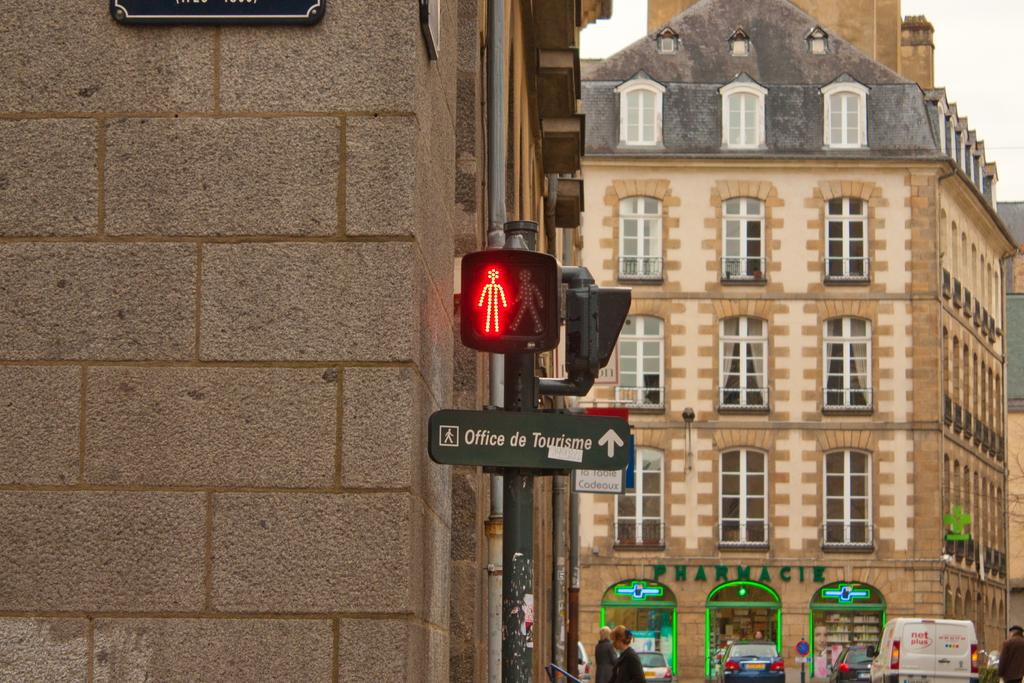Provide a one-sentence caption for the provided image. A street sign pointing toward the Office de Tourism straight ahead. 